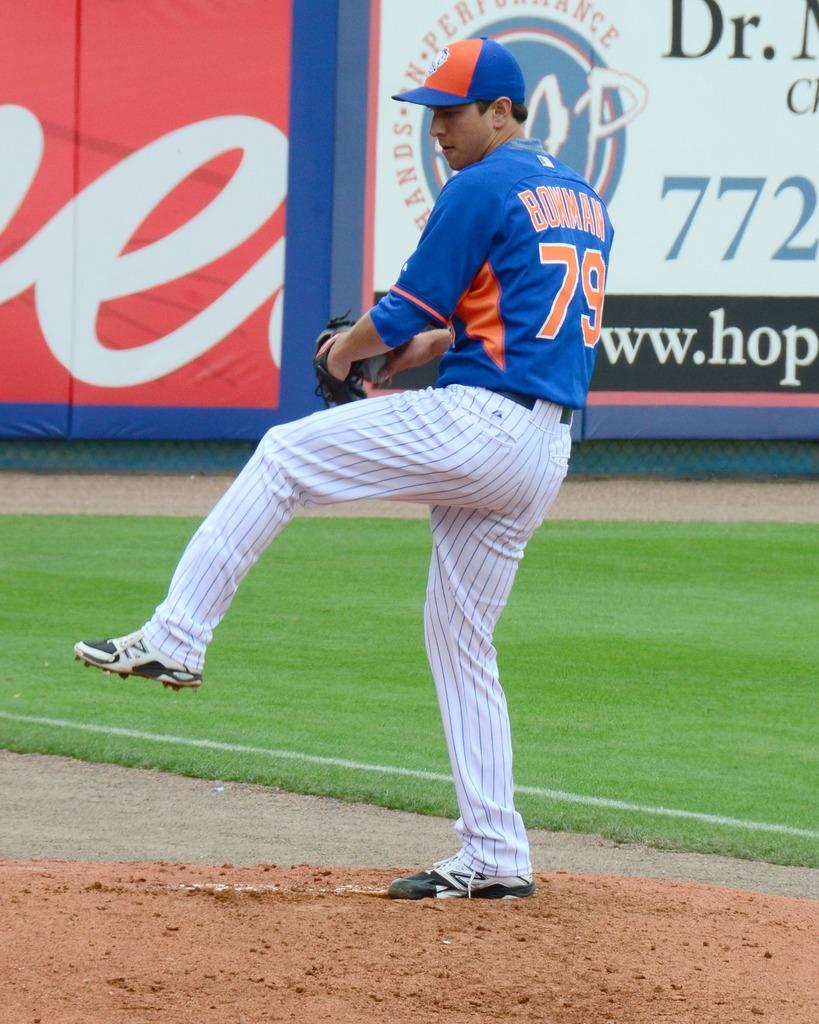<image>
Describe the image concisely. Player number 79 has one leg up as he prepares to throw the ball. 